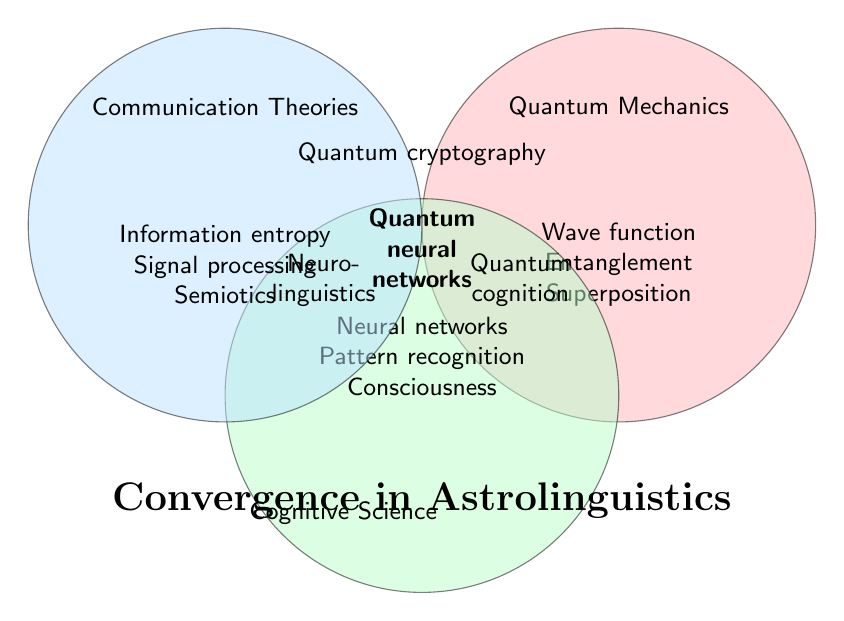What are the unique phenomena listed under Cognitive Science? The green circle, representing Cognitive Science, lists Neural networks, Pattern recognition, and Consciousness studies as unique phenomena.
Answer: Neural networks, Pattern recognition, Consciousness studies Which field has the concept of Wave function collapse? The concept of Wave function collapse is listed under the red circle, which represents Quantum Mechanics.
Answer: Quantum Mechanics What is noted at the intersection of Cognitive Science and Communication Theories? At the intersection of the green and blue circles, Neurolinguistics is listed.
Answer: Neurolinguistics Name a phenomenon that combines aspects from Quantum Mechanics and Cognitive Science but not from Communication Theories. The intersection of the red and green circles, which represent Quantum Mechanics and Cognitive Science, lists Quantum cognition.
Answer: Quantum cognition What is the significance of the center overlap of all three circles? The center overlap of all three circles highlights the convergence of Quantum Mechanics, Cognitive Science, and Communication Theories, represented by Quantum neural networks.
Answer: Quantum neural networks How many unique phenomena are listed under Communication Theories in the diagram? The blue circle, representing Communication Theories, lists Information entropy, Signal processing, and Semiotics. There are three unique phenomena.
Answer: 3 What common concept exists between Quantum Mechanics and Communication Theories? The overlap between the red and blue circles shows Quantum cryptography as the common concept.
Answer: Quantum cryptography Identify one phenomenon that lies entirely within the Quantum Mechanics circle but not at any intersection. Within the red circle, separated from intersections, Wave function collapse, Entanglement, and Superposition are listed; any one of these can be the answer.
Answer: Wave function collapse / Entanglement / Superposition What inter-disciplinary area connects Cognitive Science and Quantum Mechanics? The overlap between the green and red circles, showing Quantum cognition as the connecting area, involves both Cognitive Science and Quantum Mechanics.
Answer: Quantum cognition Compare the intersection areas: Which one contains more specific concepts, the intersection of Quantum Mechanics and Cognitive Science, or the intersection of Cognitive Science and Communication Theories? The intersection of Quantum Mechanics and Cognitive Science lists Quantum cognition as a specific concept, whereas the intersection of Cognitive Science and Communication Theories lists Neurolinguistics. Both intersections list exactly one specific concept.
Answer: Equal (both list one concept) 